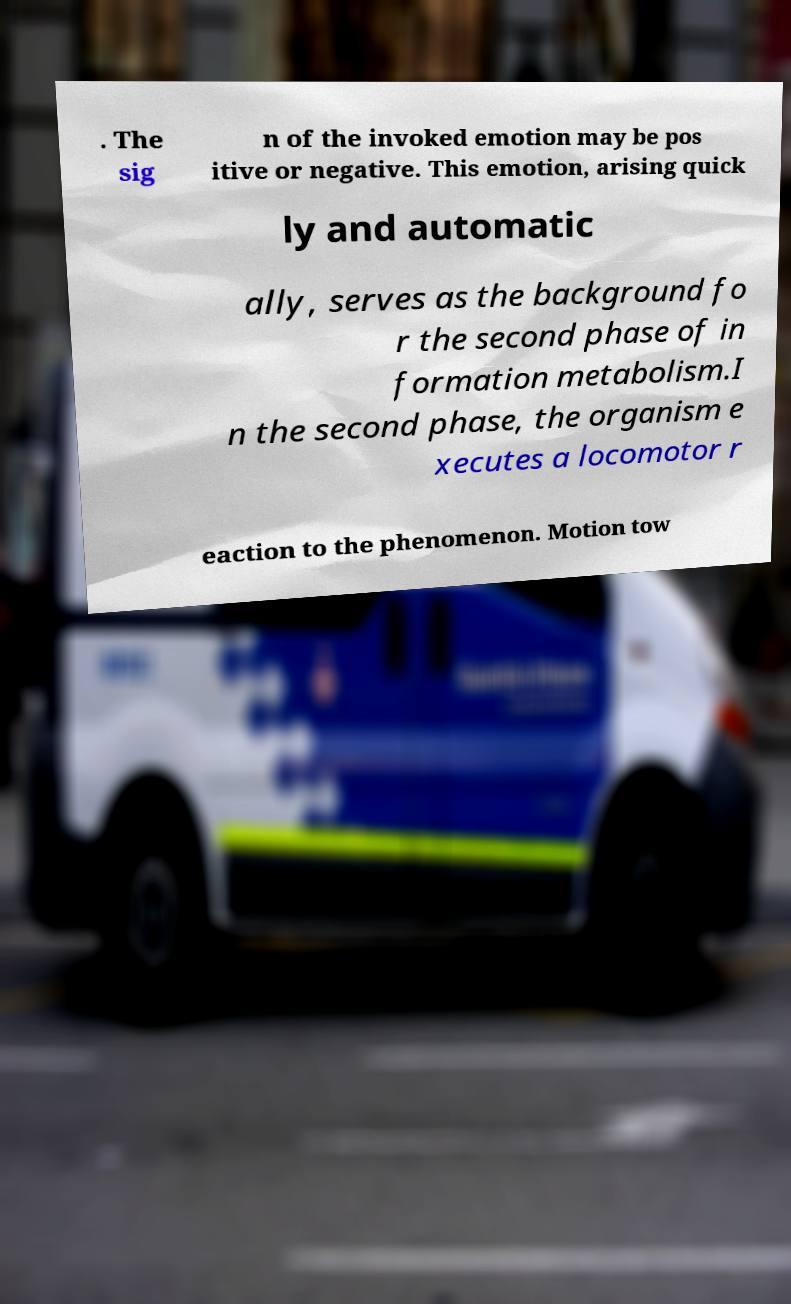Could you extract and type out the text from this image? . The sig n of the invoked emotion may be pos itive or negative. This emotion, arising quick ly and automatic ally, serves as the background fo r the second phase of in formation metabolism.I n the second phase, the organism e xecutes a locomotor r eaction to the phenomenon. Motion tow 